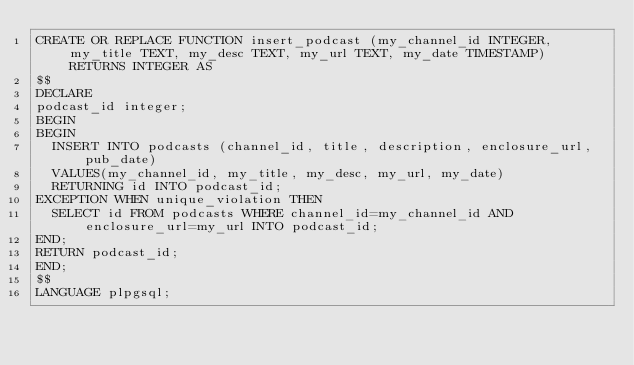<code> <loc_0><loc_0><loc_500><loc_500><_SQL_>CREATE OR REPLACE FUNCTION insert_podcast (my_channel_id INTEGER, my_title TEXT, my_desc TEXT, my_url TEXT, my_date TIMESTAMP) RETURNS INTEGER AS
$$
DECLARE
podcast_id integer;
BEGIN
BEGIN
  INSERT INTO podcasts (channel_id, title, description, enclosure_url, pub_date)
  VALUES(my_channel_id, my_title, my_desc, my_url, my_date)
  RETURNING id INTO podcast_id;
EXCEPTION WHEN unique_violation THEN
  SELECT id FROM podcasts WHERE channel_id=my_channel_id AND enclosure_url=my_url INTO podcast_id;
END;
RETURN podcast_id;
END;
$$
LANGUAGE plpgsql;</code> 